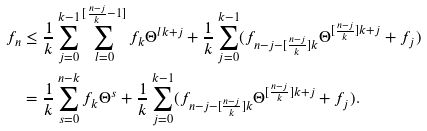<formula> <loc_0><loc_0><loc_500><loc_500>f _ { n } & \leq \frac { 1 } { k } \sum _ { j = 0 } ^ { k - 1 } \sum _ { l = 0 } ^ { [ \frac { n - j } { k } - 1 ] } f _ { k } \Theta ^ { l k + j } + \frac { 1 } { k } \sum _ { j = 0 } ^ { k - 1 } ( f _ { n - j - [ \frac { n - j } { k } ] k } \Theta ^ { [ \frac { n - j } { k } ] k + j } + f _ { j } ) \\ & = \frac { 1 } { k } \sum _ { s = 0 } ^ { n - k } f _ { k } \Theta ^ { s } + \frac { 1 } { k } \sum _ { j = 0 } ^ { k - 1 } ( f _ { n - j - [ \frac { n - j } { k } ] k } \Theta ^ { [ \frac { n - j } { k } ] k + j } + f _ { j } ) .</formula> 